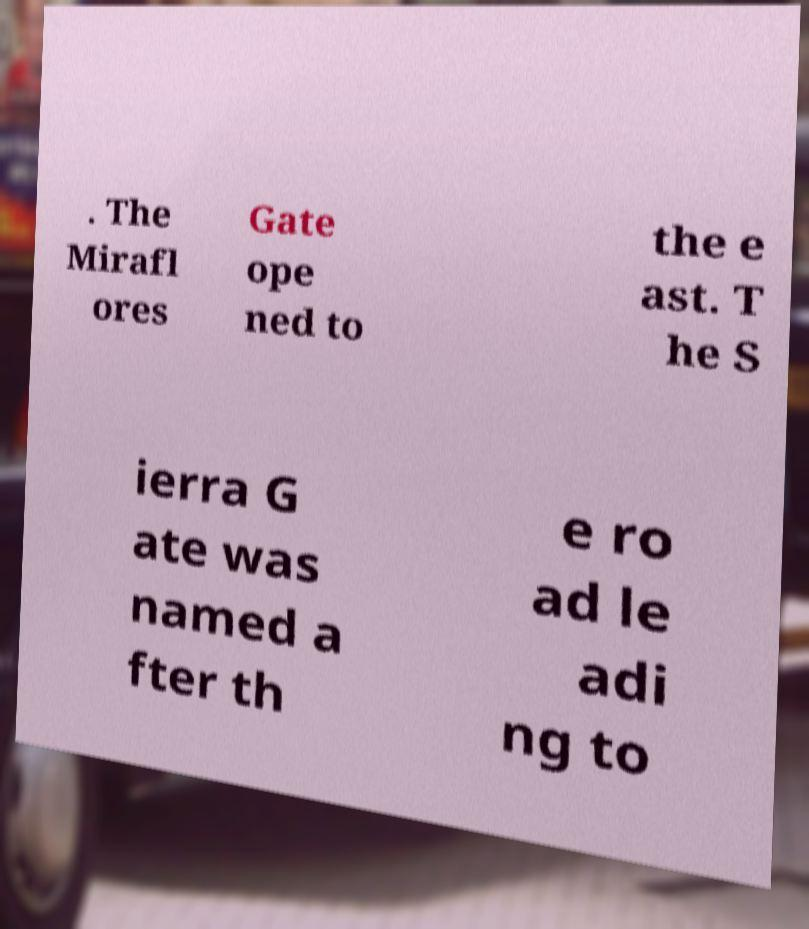I need the written content from this picture converted into text. Can you do that? . The Mirafl ores Gate ope ned to the e ast. T he S ierra G ate was named a fter th e ro ad le adi ng to 